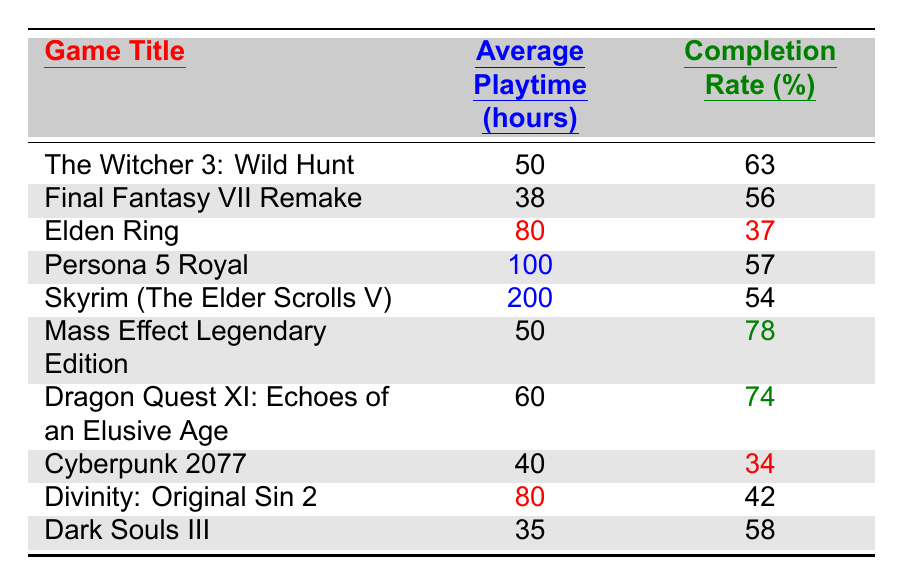What is the average playtime of "The Witcher 3: Wild Hunt"? The table clearly states that the average playtime for "The Witcher 3: Wild Hunt" is listed under the "Average Playtime (hours)" column and is 50 hours.
Answer: 50 hours What is the completion rate for "Elden Ring"? Referring to the table, the completion rate for "Elden Ring" is found under the "Completion Rate (%)" column, which shows 37%.
Answer: 37% Which game has the highest completion rate? By examining the completion rate values in the associated column, "Mass Effect Legendary Edition" has the highest completion rate at 78%.
Answer: Mass Effect Legendary Edition What is the average playtime of all the listed RPGs? To find the average playtime, sum up the average playtimes of all games: 50 + 38 + 80 + 100 + 200 + 50 + 60 + 40 + 80 + 35 = 733. Then, divide 733 by the number of games (10), which equals 73.3 hours.
Answer: 73.3 hours Is "Dragon Quest XI: Echoes of an Elusive Age" above or below the average completion rate for RPGs in this table? The average completion rate is calculated by summing all completion rates: 63 + 56 + 37 + 57 + 54 + 78 + 74 + 34 + 42 + 58 =  59.4%. "Dragon Quest XI" has a completion rate of 74%, which is above the average.
Answer: Above What is the difference in average playtime between "Persona 5 Royal" and "Dark Souls III"? The average playtime for "Persona 5 Royal" is 100 hours and for "Dark Souls III" it is 35 hours. Subtracting these gives 100 - 35 = 65 hours.
Answer: 65 hours Which game has the lowest completion rate, and how much lower is it compared to the highest completion rate? "Cyberpunk 2077" has the lowest completion rate at 34%. The highest completion rate is "Mass Effect Legendary Edition" at 78%. The difference is 78 - 34 = 44%.
Answer: 44% What can be inferred about the relationship between average playtime and completion rates? From the table, we observe that generally higher average playtimes do not correlate with higher completion rates; for instance, "Skyrim" has a long playtime of 200 hours yet a lower completion rate of 54%.
Answer: Varies; no clear correlation 